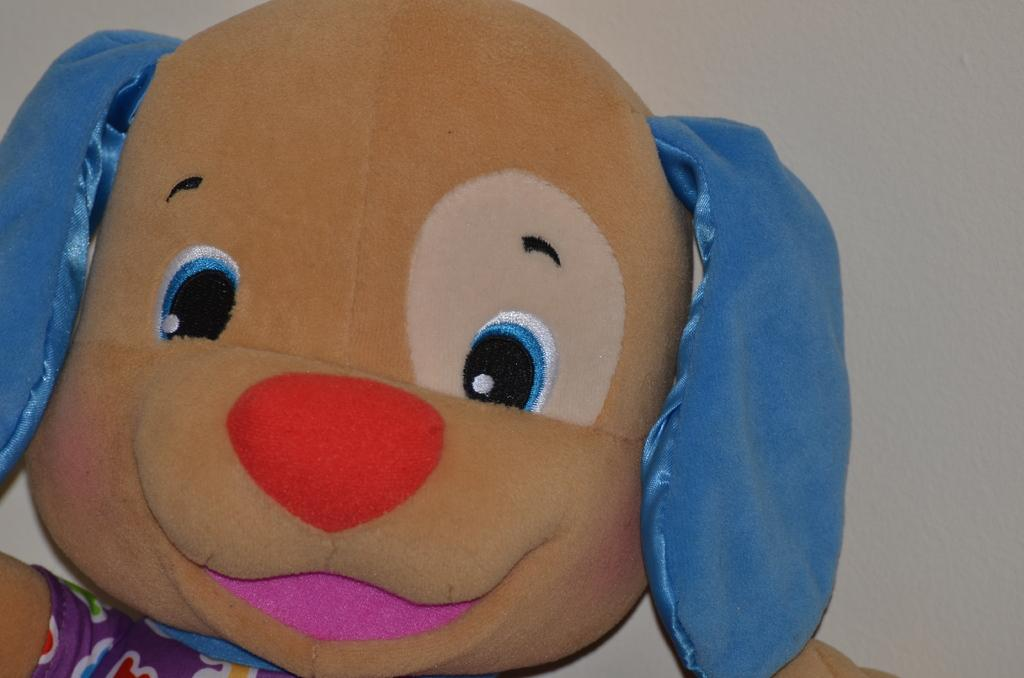What object can be seen in the image? There is a toy in the image. What can be seen in the background of the image? There is a wall in the background of the image. How many rabbits are hopping on the toy in the image? There are no rabbits present in the image, and the toy does not depict any rabbits. 